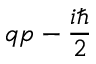<formula> <loc_0><loc_0><loc_500><loc_500>q p - { \frac { i } { 2 } }</formula> 